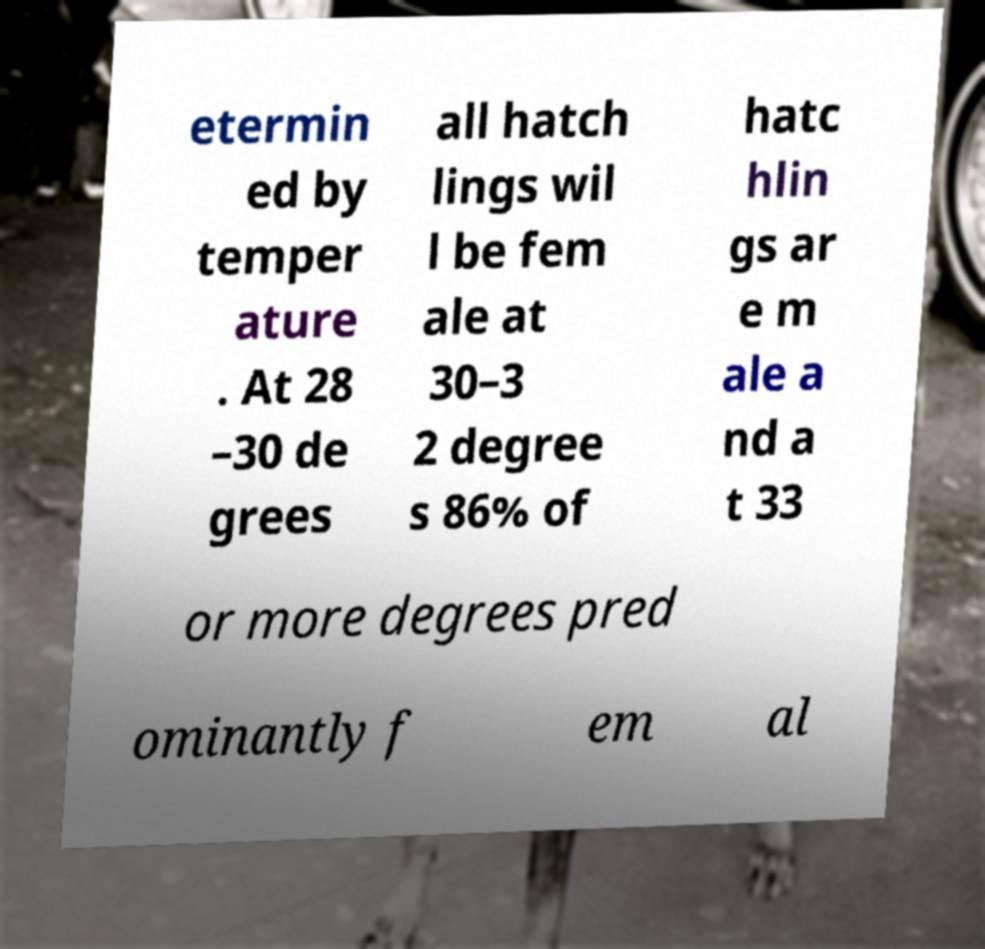For documentation purposes, I need the text within this image transcribed. Could you provide that? etermin ed by temper ature . At 28 –30 de grees all hatch lings wil l be fem ale at 30–3 2 degree s 86% of hatc hlin gs ar e m ale a nd a t 33 or more degrees pred ominantly f em al 